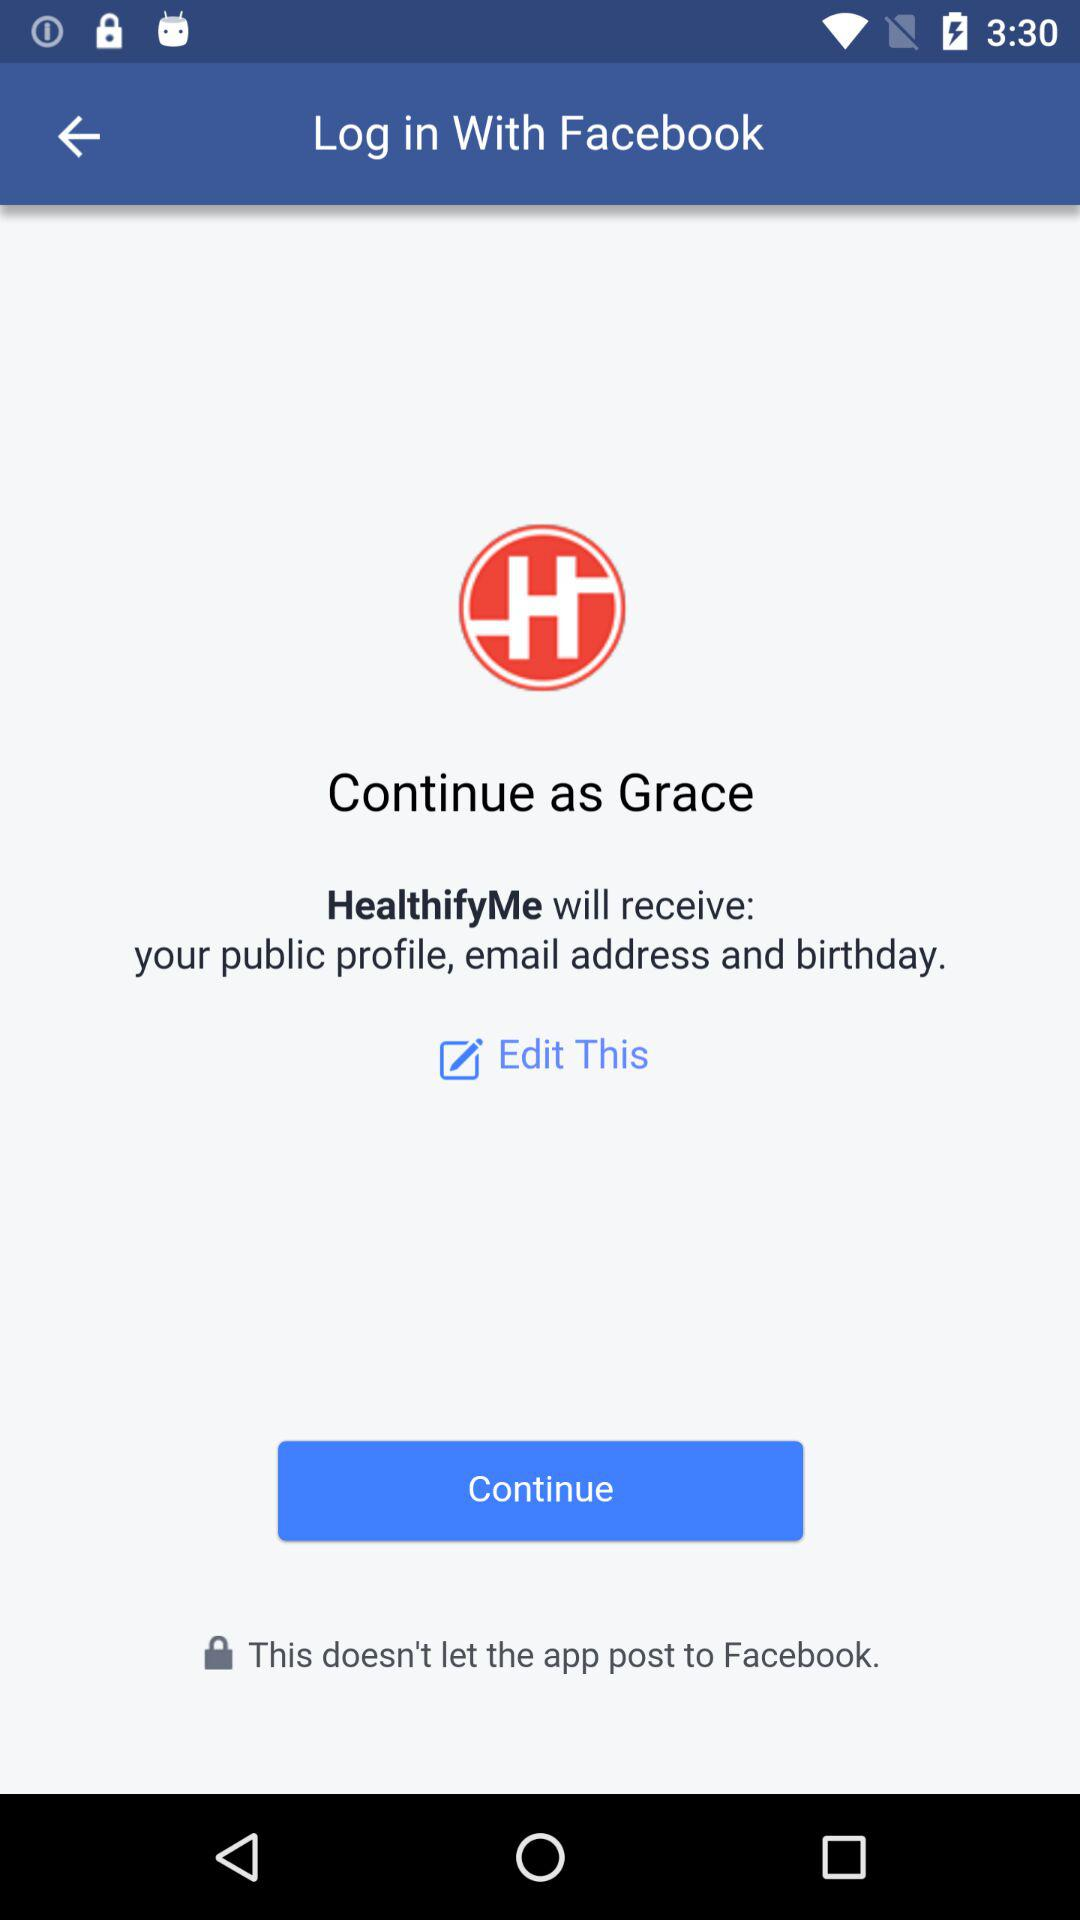What is the version of this application?
When the provided information is insufficient, respond with <no answer>. <no answer> 